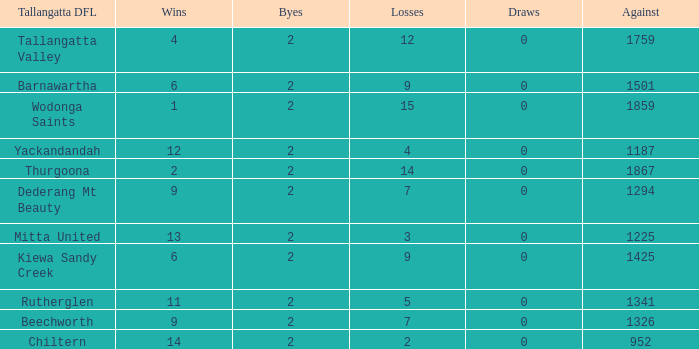What are the fewest draws with less than 7 losses and Mitta United is the Tallagatta DFL? 0.0. 